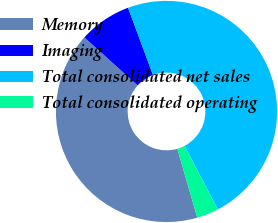Convert chart to OTSL. <chart><loc_0><loc_0><loc_500><loc_500><pie_chart><fcel>Memory<fcel>Imaging<fcel>Total consolidated net sales<fcel>Total consolidated operating<nl><fcel>41.17%<fcel>7.67%<fcel>47.98%<fcel>3.19%<nl></chart> 